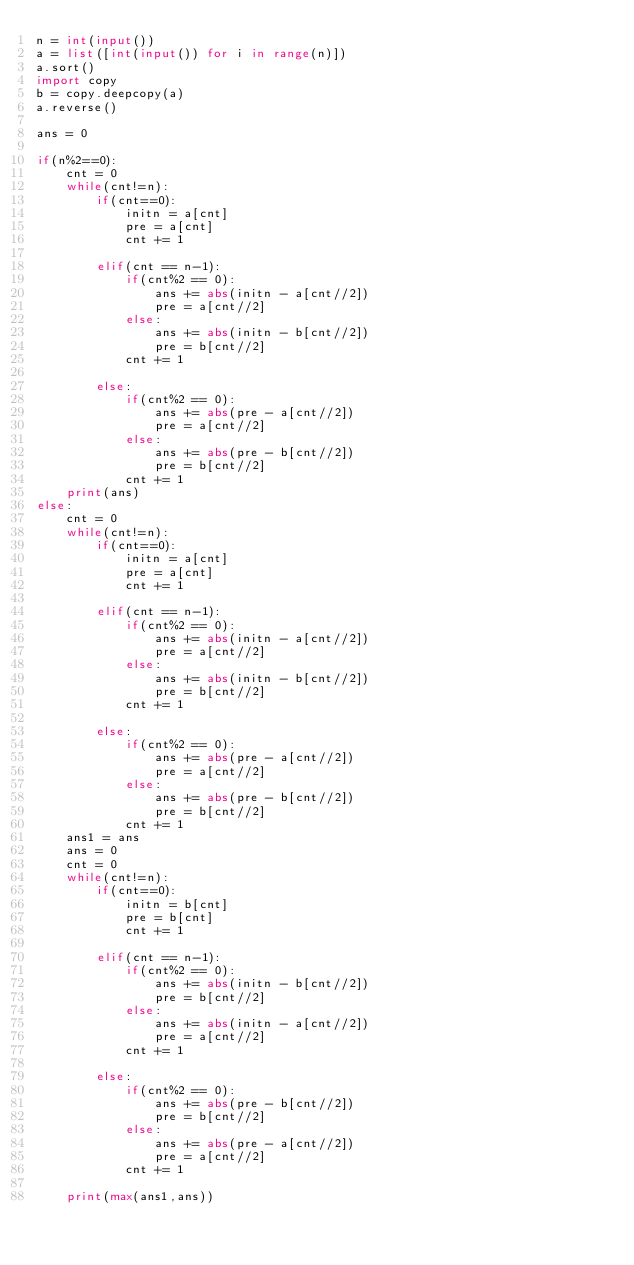Convert code to text. <code><loc_0><loc_0><loc_500><loc_500><_Python_>n = int(input())
a = list([int(input()) for i in range(n)])
a.sort()
import copy
b = copy.deepcopy(a)
a.reverse()

ans = 0

if(n%2==0):
    cnt = 0
    while(cnt!=n):
        if(cnt==0):
            initn = a[cnt]
            pre = a[cnt]
            cnt += 1

        elif(cnt == n-1):
            if(cnt%2 == 0):
                ans += abs(initn - a[cnt//2])
                pre = a[cnt//2]
            else:
                ans += abs(initn - b[cnt//2])
                pre = b[cnt//2]
            cnt += 1
            
        else:
            if(cnt%2 == 0):
                ans += abs(pre - a[cnt//2])
                pre = a[cnt//2]
            else:
                ans += abs(pre - b[cnt//2])
                pre = b[cnt//2]
            cnt += 1
    print(ans)
else:
    cnt = 0
    while(cnt!=n):
        if(cnt==0):
            initn = a[cnt]
            pre = a[cnt]
            cnt += 1

        elif(cnt == n-1):
            if(cnt%2 == 0):
                ans += abs(initn - a[cnt//2])
                pre = a[cnt//2]
            else:
                ans += abs(initn - b[cnt//2])
                pre = b[cnt//2]
            cnt += 1
            
        else:
            if(cnt%2 == 0):
                ans += abs(pre - a[cnt//2])
                pre = a[cnt//2]
            else:
                ans += abs(pre - b[cnt//2])
                pre = b[cnt//2]
            cnt += 1
    ans1 = ans
    ans = 0
    cnt = 0
    while(cnt!=n):
        if(cnt==0):
            initn = b[cnt]
            pre = b[cnt]
            cnt += 1

        elif(cnt == n-1):
            if(cnt%2 == 0):
                ans += abs(initn - b[cnt//2])
                pre = b[cnt//2]
            else:
                ans += abs(initn - a[cnt//2])
                pre = a[cnt//2]
            cnt += 1
            
        else:
            if(cnt%2 == 0):
                ans += abs(pre - b[cnt//2])
                pre = b[cnt//2]
            else:
                ans += abs(pre - a[cnt//2])
                pre = a[cnt//2]
            cnt += 1
    
    print(max(ans1,ans))</code> 